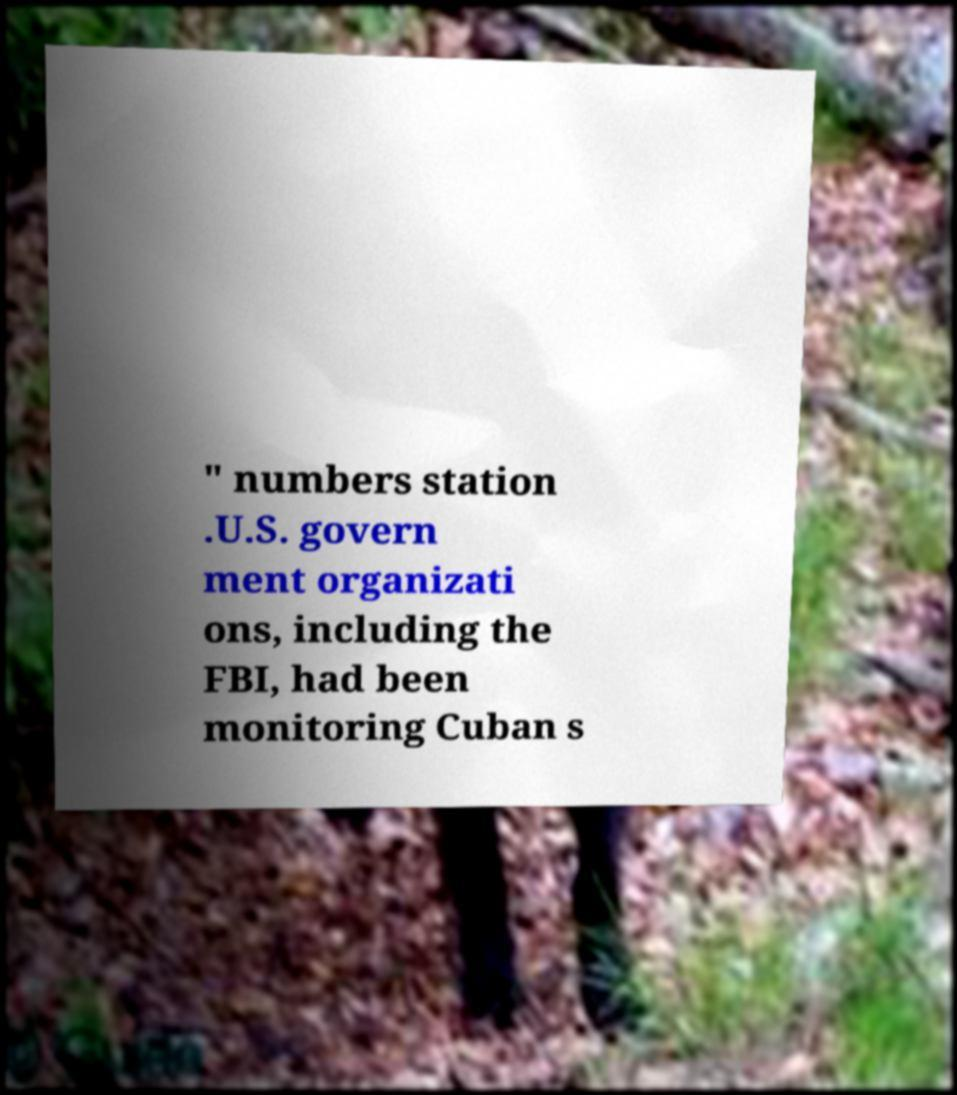There's text embedded in this image that I need extracted. Can you transcribe it verbatim? " numbers station .U.S. govern ment organizati ons, including the FBI, had been monitoring Cuban s 